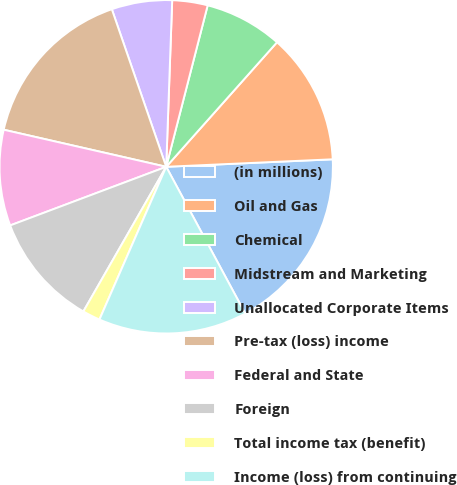Convert chart to OTSL. <chart><loc_0><loc_0><loc_500><loc_500><pie_chart><fcel>(in millions)<fcel>Oil and Gas<fcel>Chemical<fcel>Midstream and Marketing<fcel>Unallocated Corporate Items<fcel>Pre-tax (loss) income<fcel>Federal and State<fcel>Foreign<fcel>Total income tax (benefit)<fcel>Income (loss) from continuing<nl><fcel>17.85%<fcel>12.71%<fcel>7.57%<fcel>3.43%<fcel>5.86%<fcel>16.14%<fcel>9.29%<fcel>11.0%<fcel>1.72%<fcel>14.42%<nl></chart> 